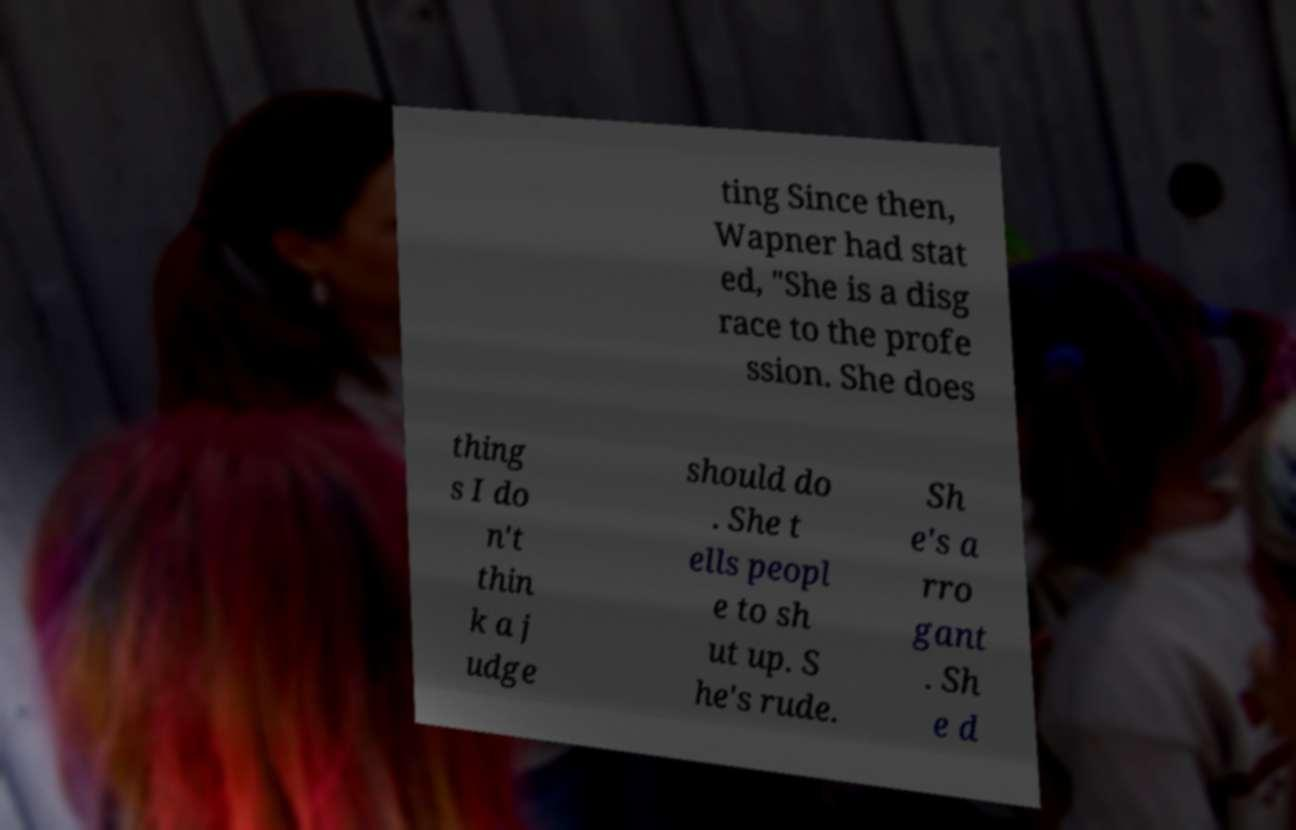Can you read and provide the text displayed in the image?This photo seems to have some interesting text. Can you extract and type it out for me? ting Since then, Wapner had stat ed, "She is a disg race to the profe ssion. She does thing s I do n't thin k a j udge should do . She t ells peopl e to sh ut up. S he's rude. Sh e's a rro gant . Sh e d 